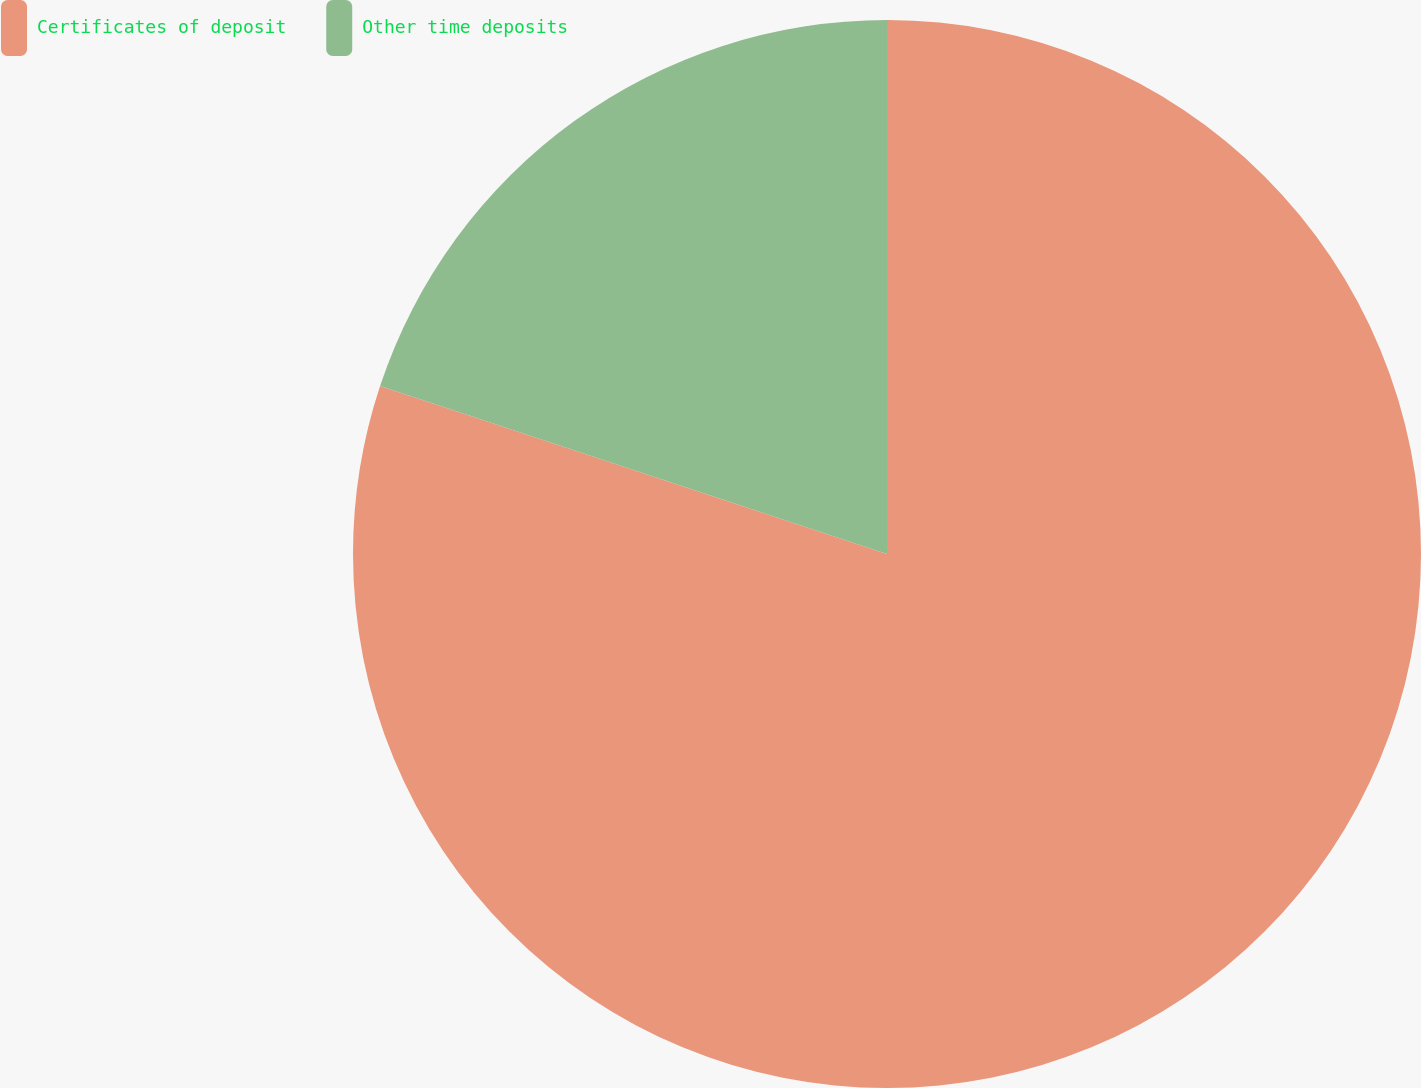Convert chart. <chart><loc_0><loc_0><loc_500><loc_500><pie_chart><fcel>Certificates of deposit<fcel>Other time deposits<nl><fcel>80.09%<fcel>19.91%<nl></chart> 